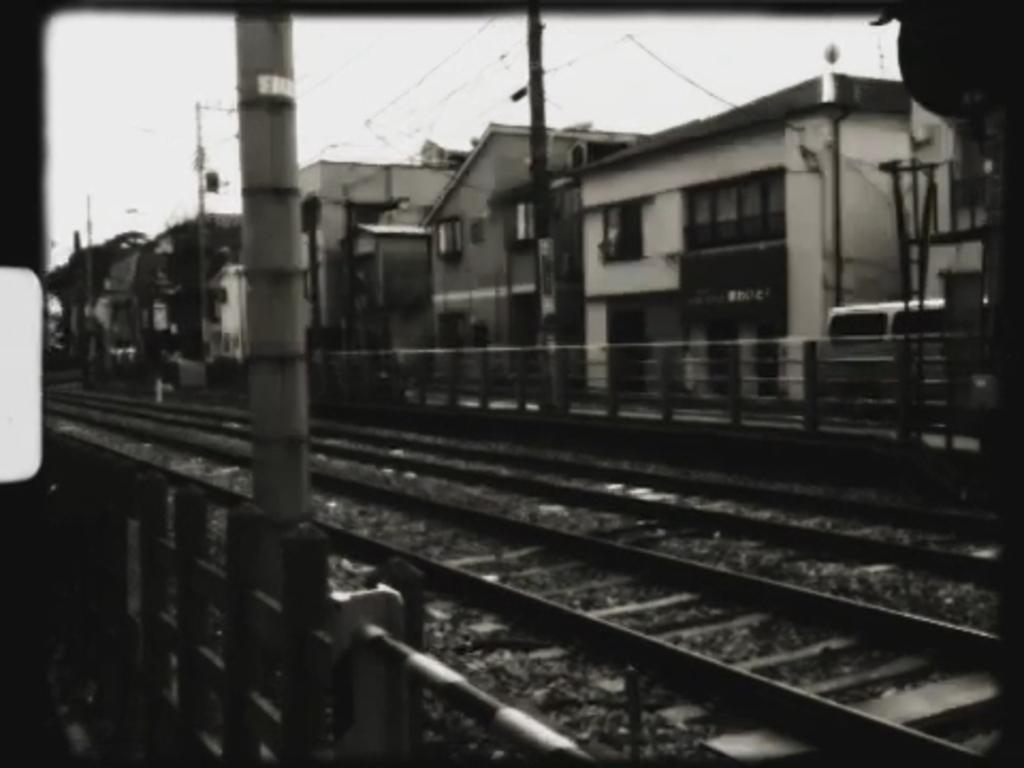What type of transportation infrastructure is shown in the image? There are railway tracks in the image. What can be seen beside the railway tracks? There are fences beside the railway tracks. What else is visible in the image besides the railway tracks and fences? There are buildings, a vehicle, poles, and some unspecified objects visible in the image. What part of the natural environment is visible in the image? The sky is visible in the image. What type of toe is visible in the image? There are no toes present in the image. Is there any poison visible in the image? There is no poison present in the image. 